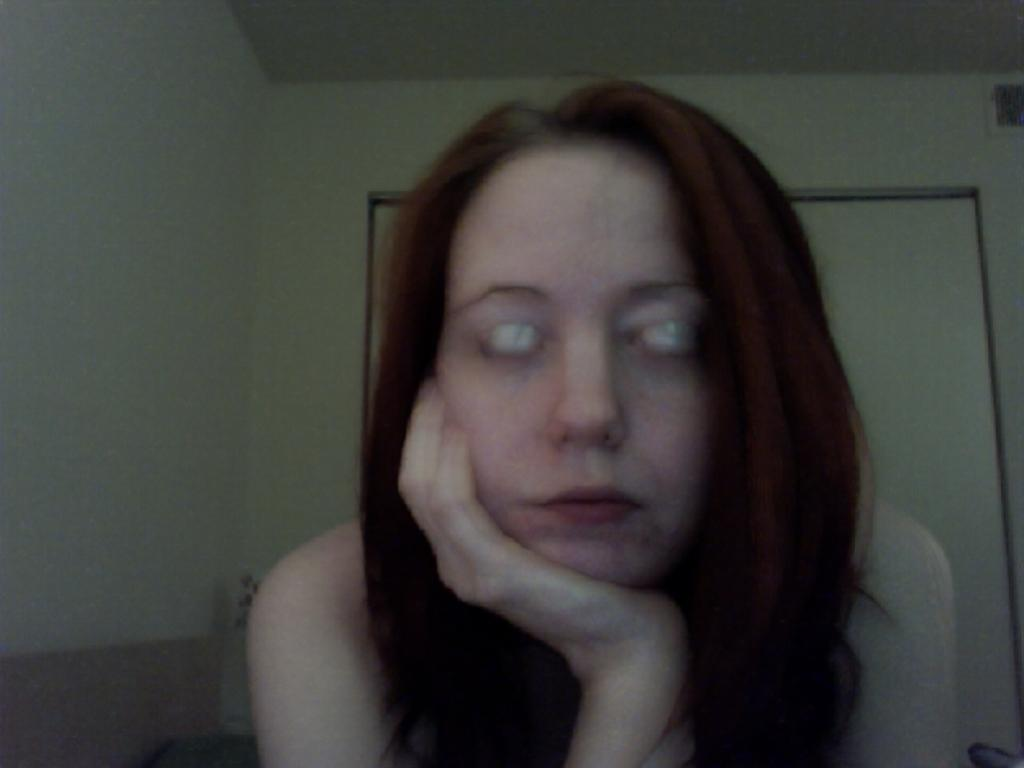Who is present in the image? There is a lady in the image. What can be seen in the background of the image? There is a wall with doors in the background of the image. What type of pie is the lady holding in the image? There is no pie present in the image; the lady is not holding anything. 